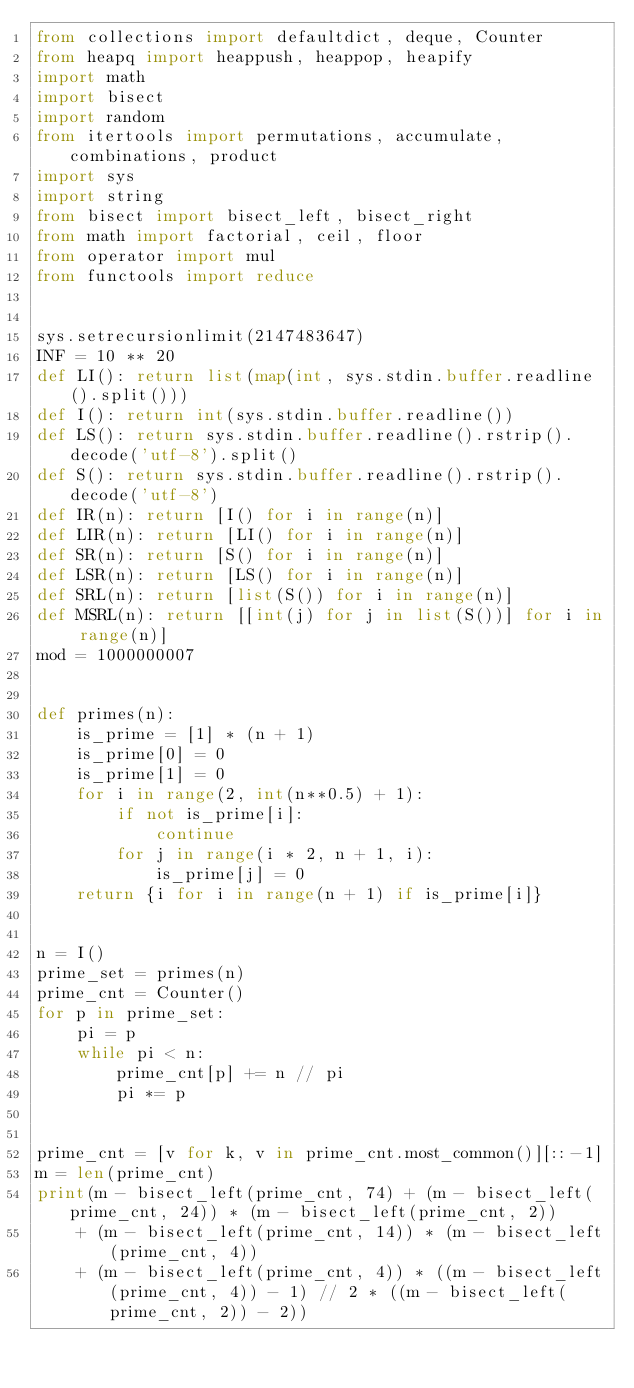Convert code to text. <code><loc_0><loc_0><loc_500><loc_500><_Python_>from collections import defaultdict, deque, Counter
from heapq import heappush, heappop, heapify
import math
import bisect
import random
from itertools import permutations, accumulate, combinations, product
import sys
import string
from bisect import bisect_left, bisect_right
from math import factorial, ceil, floor
from operator import mul
from functools import reduce


sys.setrecursionlimit(2147483647)
INF = 10 ** 20
def LI(): return list(map(int, sys.stdin.buffer.readline().split()))
def I(): return int(sys.stdin.buffer.readline())
def LS(): return sys.stdin.buffer.readline().rstrip().decode('utf-8').split()
def S(): return sys.stdin.buffer.readline().rstrip().decode('utf-8')
def IR(n): return [I() for i in range(n)]
def LIR(n): return [LI() for i in range(n)]
def SR(n): return [S() for i in range(n)]
def LSR(n): return [LS() for i in range(n)]
def SRL(n): return [list(S()) for i in range(n)]
def MSRL(n): return [[int(j) for j in list(S())] for i in range(n)]
mod = 1000000007


def primes(n):
    is_prime = [1] * (n + 1)
    is_prime[0] = 0
    is_prime[1] = 0
    for i in range(2, int(n**0.5) + 1):
        if not is_prime[i]:
            continue
        for j in range(i * 2, n + 1, i):
            is_prime[j] = 0
    return {i for i in range(n + 1) if is_prime[i]}


n = I()
prime_set = primes(n)
prime_cnt = Counter()
for p in prime_set:
    pi = p
    while pi < n:
        prime_cnt[p] += n // pi
        pi *= p


prime_cnt = [v for k, v in prime_cnt.most_common()][::-1]
m = len(prime_cnt)
print(m - bisect_left(prime_cnt, 74) + (m - bisect_left(prime_cnt, 24)) * (m - bisect_left(prime_cnt, 2))
    + (m - bisect_left(prime_cnt, 14)) * (m - bisect_left(prime_cnt, 4))
    + (m - bisect_left(prime_cnt, 4)) * ((m - bisect_left(prime_cnt, 4)) - 1) // 2 * ((m - bisect_left(prime_cnt, 2)) - 2))</code> 